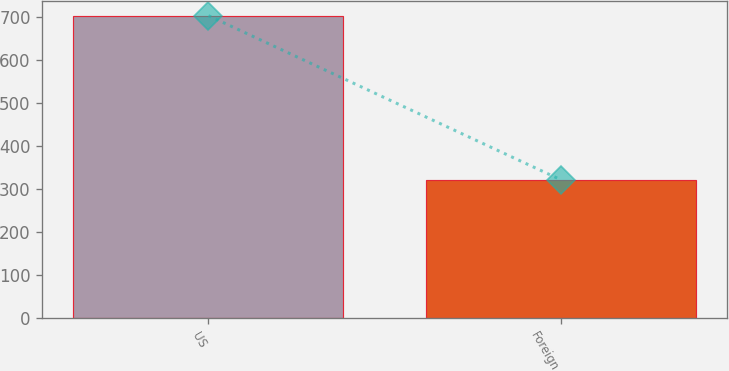Convert chart to OTSL. <chart><loc_0><loc_0><loc_500><loc_500><bar_chart><fcel>US<fcel>Foreign<nl><fcel>704<fcel>322<nl></chart> 